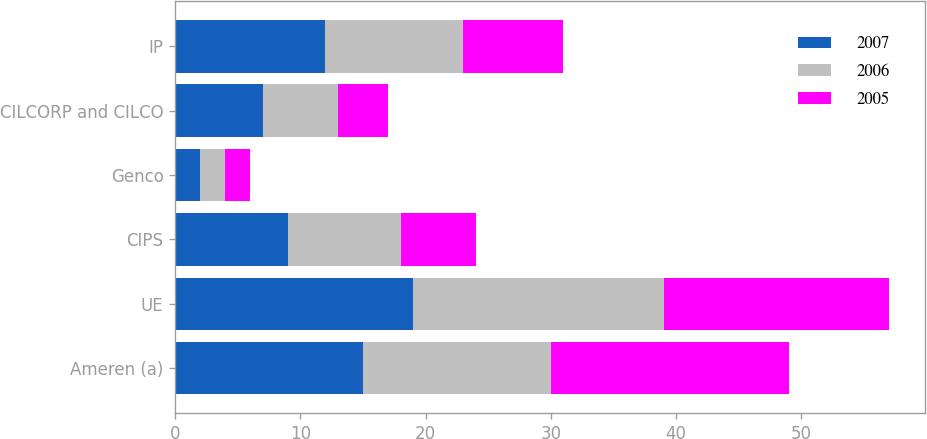Convert chart. <chart><loc_0><loc_0><loc_500><loc_500><stacked_bar_chart><ecel><fcel>Ameren (a)<fcel>UE<fcel>CIPS<fcel>Genco<fcel>CILCORP and CILCO<fcel>IP<nl><fcel>2007<fcel>15<fcel>19<fcel>9<fcel>2<fcel>7<fcel>12<nl><fcel>2006<fcel>15<fcel>20<fcel>9<fcel>2<fcel>6<fcel>11<nl><fcel>2005<fcel>19<fcel>18<fcel>6<fcel>2<fcel>4<fcel>8<nl></chart> 